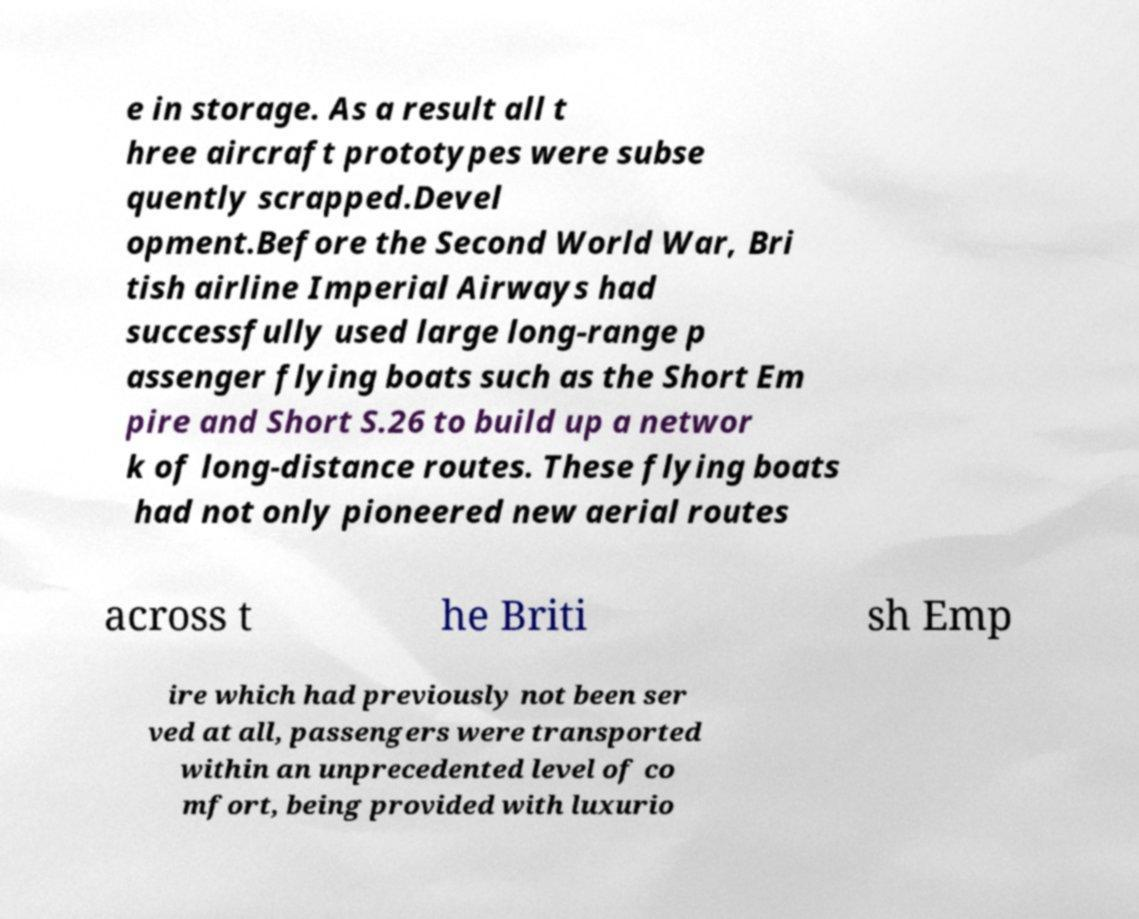For documentation purposes, I need the text within this image transcribed. Could you provide that? e in storage. As a result all t hree aircraft prototypes were subse quently scrapped.Devel opment.Before the Second World War, Bri tish airline Imperial Airways had successfully used large long-range p assenger flying boats such as the Short Em pire and Short S.26 to build up a networ k of long-distance routes. These flying boats had not only pioneered new aerial routes across t he Briti sh Emp ire which had previously not been ser ved at all, passengers were transported within an unprecedented level of co mfort, being provided with luxurio 